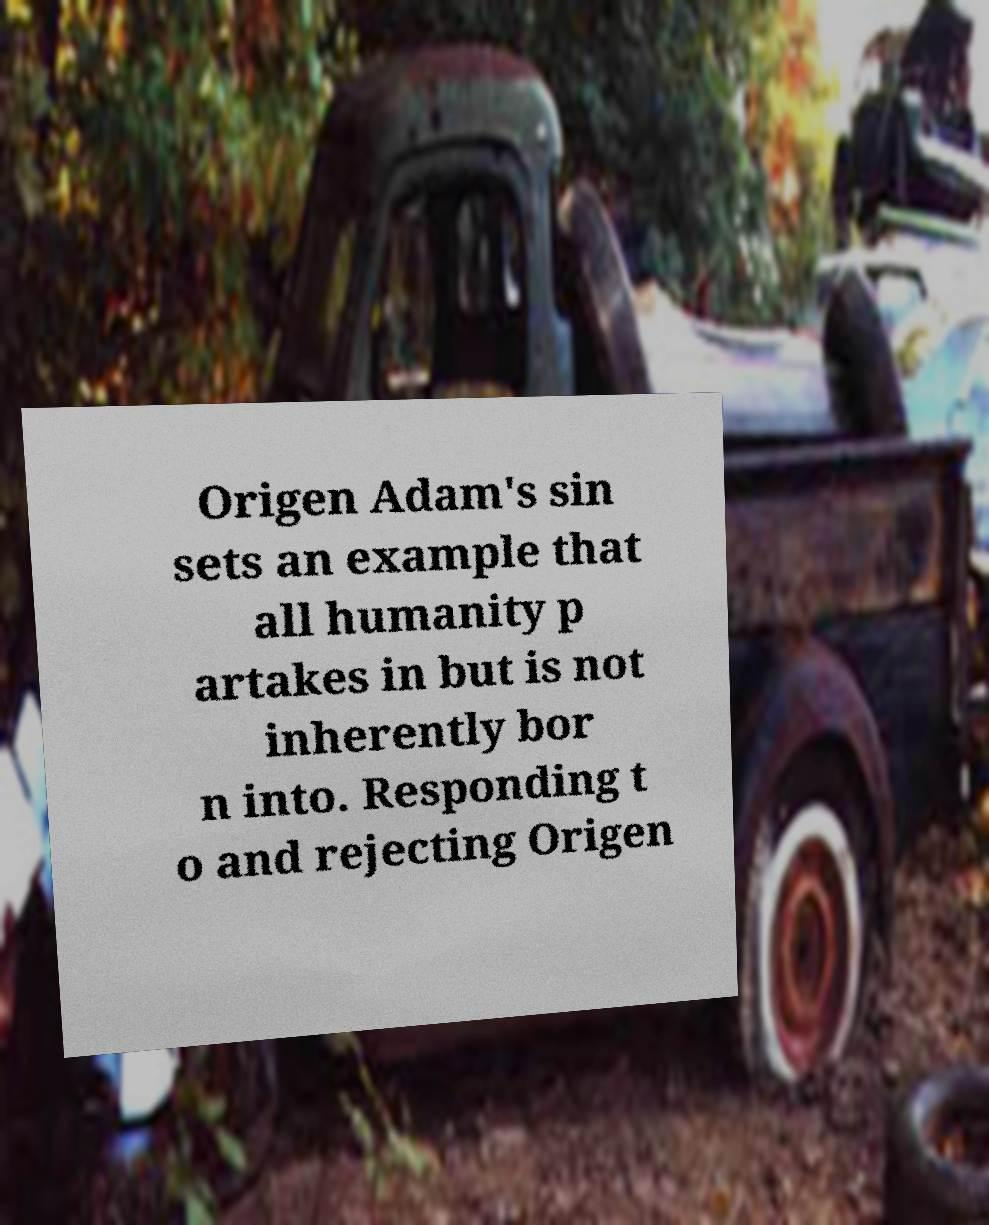Please read and relay the text visible in this image. What does it say? Origen Adam's sin sets an example that all humanity p artakes in but is not inherently bor n into. Responding t o and rejecting Origen 